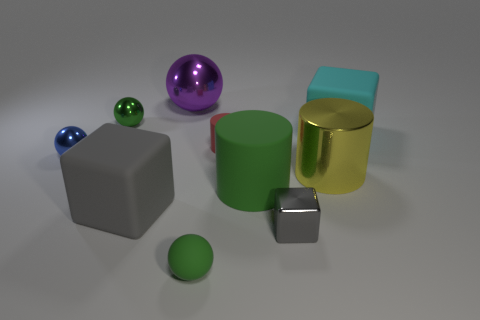What material is the big gray object that is the same shape as the large cyan object?
Your response must be concise. Rubber. How big is the shiny ball in front of the big matte object that is behind the yellow cylinder?
Keep it short and to the point. Small. There is a large rubber object that is the same color as the small block; what is its shape?
Offer a very short reply. Cube. What is the size of the green object behind the metal ball in front of the tiny metallic sphere on the right side of the blue thing?
Keep it short and to the point. Small. Are there any other cubes that have the same color as the shiny cube?
Ensure brevity in your answer.  Yes. There is a green object that is to the right of the green rubber ball; is it the same size as the large cyan rubber cube?
Keep it short and to the point. Yes. Are there the same number of purple metal things in front of the cyan matte cube and small brown shiny blocks?
Ensure brevity in your answer.  Yes. How many objects are green spheres behind the cyan rubber block or purple matte objects?
Offer a terse response. 1. The object that is both behind the metallic block and in front of the green matte cylinder has what shape?
Offer a very short reply. Cube. How many objects are either tiny green balls behind the small blue ball or objects behind the cyan block?
Keep it short and to the point. 2. 